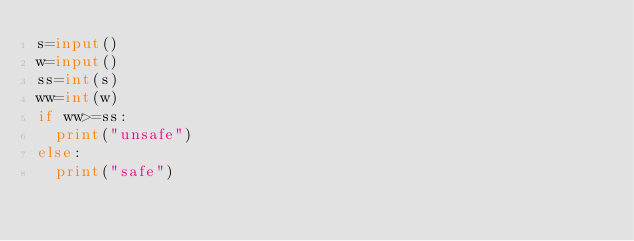<code> <loc_0><loc_0><loc_500><loc_500><_Python_>s=input()
w=input()
ss=int(s)
ww=int(w)
if ww>=ss:
  print("unsafe")
else:
  print("safe")</code> 